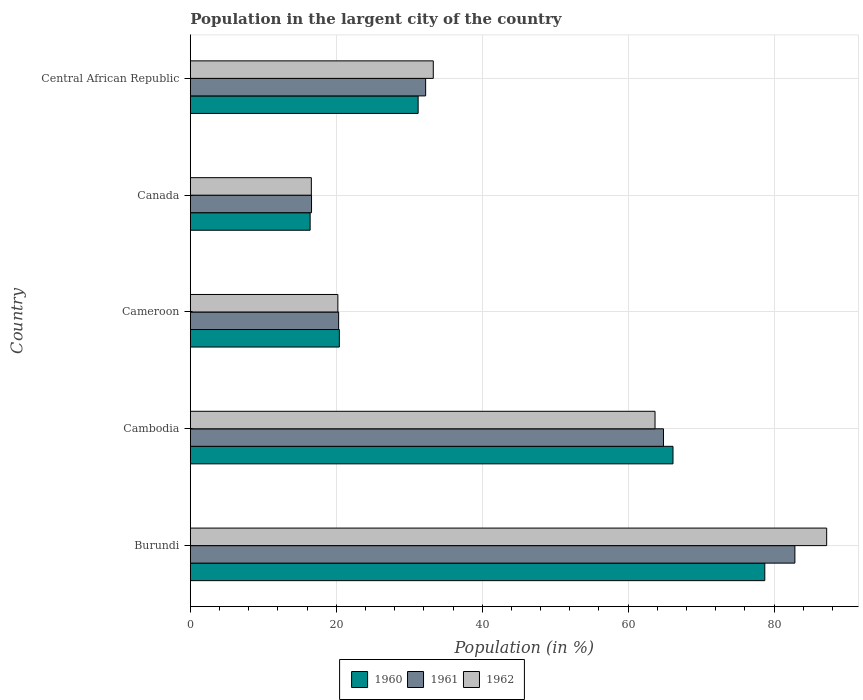How many different coloured bars are there?
Give a very brief answer. 3. Are the number of bars on each tick of the Y-axis equal?
Your response must be concise. Yes. How many bars are there on the 5th tick from the top?
Your answer should be very brief. 3. What is the label of the 4th group of bars from the top?
Offer a very short reply. Cambodia. What is the percentage of population in the largent city in 1960 in Canada?
Give a very brief answer. 16.42. Across all countries, what is the maximum percentage of population in the largent city in 1962?
Your answer should be very brief. 87.2. Across all countries, what is the minimum percentage of population in the largent city in 1962?
Keep it short and to the point. 16.59. In which country was the percentage of population in the largent city in 1962 maximum?
Provide a succinct answer. Burundi. In which country was the percentage of population in the largent city in 1960 minimum?
Your answer should be very brief. Canada. What is the total percentage of population in the largent city in 1961 in the graph?
Your response must be concise. 216.87. What is the difference between the percentage of population in the largent city in 1960 in Burundi and that in Cameroon?
Provide a succinct answer. 58.3. What is the difference between the percentage of population in the largent city in 1962 in Cameroon and the percentage of population in the largent city in 1961 in Cambodia?
Keep it short and to the point. -44.62. What is the average percentage of population in the largent city in 1960 per country?
Ensure brevity in your answer.  42.59. What is the difference between the percentage of population in the largent city in 1961 and percentage of population in the largent city in 1960 in Canada?
Keep it short and to the point. 0.19. What is the ratio of the percentage of population in the largent city in 1961 in Cambodia to that in Cameroon?
Your answer should be compact. 3.19. Is the percentage of population in the largent city in 1961 in Cameroon less than that in Canada?
Make the answer very short. No. Is the difference between the percentage of population in the largent city in 1961 in Cambodia and Canada greater than the difference between the percentage of population in the largent city in 1960 in Cambodia and Canada?
Offer a terse response. No. What is the difference between the highest and the second highest percentage of population in the largent city in 1961?
Your response must be concise. 18.01. What is the difference between the highest and the lowest percentage of population in the largent city in 1960?
Ensure brevity in your answer.  62.3. In how many countries, is the percentage of population in the largent city in 1961 greater than the average percentage of population in the largent city in 1961 taken over all countries?
Offer a terse response. 2. Is the sum of the percentage of population in the largent city in 1961 in Cambodia and Cameroon greater than the maximum percentage of population in the largent city in 1960 across all countries?
Your response must be concise. Yes. What does the 3rd bar from the top in Cambodia represents?
Your answer should be compact. 1960. Is it the case that in every country, the sum of the percentage of population in the largent city in 1960 and percentage of population in the largent city in 1962 is greater than the percentage of population in the largent city in 1961?
Your response must be concise. Yes. How many bars are there?
Keep it short and to the point. 15. How many countries are there in the graph?
Offer a terse response. 5. What is the difference between two consecutive major ticks on the X-axis?
Provide a short and direct response. 20. Are the values on the major ticks of X-axis written in scientific E-notation?
Your answer should be very brief. No. Where does the legend appear in the graph?
Give a very brief answer. Bottom center. How many legend labels are there?
Keep it short and to the point. 3. What is the title of the graph?
Ensure brevity in your answer.  Population in the largent city of the country. Does "1973" appear as one of the legend labels in the graph?
Your answer should be compact. No. What is the label or title of the X-axis?
Keep it short and to the point. Population (in %). What is the label or title of the Y-axis?
Ensure brevity in your answer.  Country. What is the Population (in %) of 1960 in Burundi?
Your answer should be very brief. 78.72. What is the Population (in %) in 1961 in Burundi?
Offer a terse response. 82.84. What is the Population (in %) of 1962 in Burundi?
Ensure brevity in your answer.  87.2. What is the Population (in %) of 1960 in Cambodia?
Keep it short and to the point. 66.14. What is the Population (in %) of 1961 in Cambodia?
Your response must be concise. 64.84. What is the Population (in %) in 1962 in Cambodia?
Keep it short and to the point. 63.68. What is the Population (in %) of 1960 in Cameroon?
Provide a short and direct response. 20.42. What is the Population (in %) in 1961 in Cameroon?
Your answer should be very brief. 20.33. What is the Population (in %) of 1962 in Cameroon?
Provide a short and direct response. 20.22. What is the Population (in %) of 1960 in Canada?
Give a very brief answer. 16.42. What is the Population (in %) in 1961 in Canada?
Your answer should be very brief. 16.61. What is the Population (in %) in 1962 in Canada?
Give a very brief answer. 16.59. What is the Population (in %) in 1960 in Central African Republic?
Make the answer very short. 31.22. What is the Population (in %) in 1961 in Central African Republic?
Your answer should be compact. 32.25. What is the Population (in %) in 1962 in Central African Republic?
Your answer should be very brief. 33.29. Across all countries, what is the maximum Population (in %) of 1960?
Your answer should be compact. 78.72. Across all countries, what is the maximum Population (in %) of 1961?
Make the answer very short. 82.84. Across all countries, what is the maximum Population (in %) in 1962?
Give a very brief answer. 87.2. Across all countries, what is the minimum Population (in %) in 1960?
Offer a very short reply. 16.42. Across all countries, what is the minimum Population (in %) in 1961?
Provide a succinct answer. 16.61. Across all countries, what is the minimum Population (in %) of 1962?
Ensure brevity in your answer.  16.59. What is the total Population (in %) in 1960 in the graph?
Provide a succinct answer. 212.93. What is the total Population (in %) in 1961 in the graph?
Your response must be concise. 216.87. What is the total Population (in %) in 1962 in the graph?
Keep it short and to the point. 220.98. What is the difference between the Population (in %) of 1960 in Burundi and that in Cambodia?
Your answer should be compact. 12.58. What is the difference between the Population (in %) of 1961 in Burundi and that in Cambodia?
Ensure brevity in your answer.  18.01. What is the difference between the Population (in %) in 1962 in Burundi and that in Cambodia?
Your answer should be compact. 23.52. What is the difference between the Population (in %) of 1960 in Burundi and that in Cameroon?
Ensure brevity in your answer.  58.3. What is the difference between the Population (in %) of 1961 in Burundi and that in Cameroon?
Ensure brevity in your answer.  62.52. What is the difference between the Population (in %) in 1962 in Burundi and that in Cameroon?
Your answer should be very brief. 66.98. What is the difference between the Population (in %) of 1960 in Burundi and that in Canada?
Make the answer very short. 62.3. What is the difference between the Population (in %) in 1961 in Burundi and that in Canada?
Offer a very short reply. 66.23. What is the difference between the Population (in %) in 1962 in Burundi and that in Canada?
Keep it short and to the point. 70.61. What is the difference between the Population (in %) in 1960 in Burundi and that in Central African Republic?
Provide a short and direct response. 47.5. What is the difference between the Population (in %) in 1961 in Burundi and that in Central African Republic?
Keep it short and to the point. 50.6. What is the difference between the Population (in %) of 1962 in Burundi and that in Central African Republic?
Your answer should be very brief. 53.9. What is the difference between the Population (in %) in 1960 in Cambodia and that in Cameroon?
Offer a terse response. 45.72. What is the difference between the Population (in %) in 1961 in Cambodia and that in Cameroon?
Keep it short and to the point. 44.51. What is the difference between the Population (in %) of 1962 in Cambodia and that in Cameroon?
Give a very brief answer. 43.46. What is the difference between the Population (in %) in 1960 in Cambodia and that in Canada?
Provide a short and direct response. 49.72. What is the difference between the Population (in %) in 1961 in Cambodia and that in Canada?
Ensure brevity in your answer.  48.23. What is the difference between the Population (in %) of 1962 in Cambodia and that in Canada?
Offer a very short reply. 47.09. What is the difference between the Population (in %) in 1960 in Cambodia and that in Central African Republic?
Your answer should be very brief. 34.92. What is the difference between the Population (in %) in 1961 in Cambodia and that in Central African Republic?
Provide a short and direct response. 32.59. What is the difference between the Population (in %) of 1962 in Cambodia and that in Central African Republic?
Make the answer very short. 30.39. What is the difference between the Population (in %) of 1960 in Cameroon and that in Canada?
Ensure brevity in your answer.  4. What is the difference between the Population (in %) in 1961 in Cameroon and that in Canada?
Your answer should be very brief. 3.71. What is the difference between the Population (in %) in 1962 in Cameroon and that in Canada?
Offer a very short reply. 3.63. What is the difference between the Population (in %) in 1960 in Cameroon and that in Central African Republic?
Your response must be concise. -10.8. What is the difference between the Population (in %) in 1961 in Cameroon and that in Central African Republic?
Give a very brief answer. -11.92. What is the difference between the Population (in %) of 1962 in Cameroon and that in Central African Republic?
Provide a succinct answer. -13.07. What is the difference between the Population (in %) of 1960 in Canada and that in Central African Republic?
Offer a terse response. -14.8. What is the difference between the Population (in %) of 1961 in Canada and that in Central African Republic?
Your answer should be compact. -15.64. What is the difference between the Population (in %) in 1962 in Canada and that in Central African Republic?
Offer a terse response. -16.71. What is the difference between the Population (in %) in 1960 in Burundi and the Population (in %) in 1961 in Cambodia?
Provide a succinct answer. 13.88. What is the difference between the Population (in %) of 1960 in Burundi and the Population (in %) of 1962 in Cambodia?
Give a very brief answer. 15.04. What is the difference between the Population (in %) in 1961 in Burundi and the Population (in %) in 1962 in Cambodia?
Provide a short and direct response. 19.16. What is the difference between the Population (in %) of 1960 in Burundi and the Population (in %) of 1961 in Cameroon?
Offer a very short reply. 58.39. What is the difference between the Population (in %) in 1960 in Burundi and the Population (in %) in 1962 in Cameroon?
Give a very brief answer. 58.5. What is the difference between the Population (in %) of 1961 in Burundi and the Population (in %) of 1962 in Cameroon?
Make the answer very short. 62.62. What is the difference between the Population (in %) of 1960 in Burundi and the Population (in %) of 1961 in Canada?
Your response must be concise. 62.11. What is the difference between the Population (in %) of 1960 in Burundi and the Population (in %) of 1962 in Canada?
Ensure brevity in your answer.  62.13. What is the difference between the Population (in %) of 1961 in Burundi and the Population (in %) of 1962 in Canada?
Your response must be concise. 66.26. What is the difference between the Population (in %) in 1960 in Burundi and the Population (in %) in 1961 in Central African Republic?
Keep it short and to the point. 46.47. What is the difference between the Population (in %) in 1960 in Burundi and the Population (in %) in 1962 in Central African Republic?
Provide a short and direct response. 45.43. What is the difference between the Population (in %) of 1961 in Burundi and the Population (in %) of 1962 in Central African Republic?
Ensure brevity in your answer.  49.55. What is the difference between the Population (in %) in 1960 in Cambodia and the Population (in %) in 1961 in Cameroon?
Ensure brevity in your answer.  45.82. What is the difference between the Population (in %) of 1960 in Cambodia and the Population (in %) of 1962 in Cameroon?
Your response must be concise. 45.92. What is the difference between the Population (in %) of 1961 in Cambodia and the Population (in %) of 1962 in Cameroon?
Offer a very short reply. 44.62. What is the difference between the Population (in %) of 1960 in Cambodia and the Population (in %) of 1961 in Canada?
Ensure brevity in your answer.  49.53. What is the difference between the Population (in %) of 1960 in Cambodia and the Population (in %) of 1962 in Canada?
Provide a succinct answer. 49.56. What is the difference between the Population (in %) in 1961 in Cambodia and the Population (in %) in 1962 in Canada?
Give a very brief answer. 48.25. What is the difference between the Population (in %) in 1960 in Cambodia and the Population (in %) in 1961 in Central African Republic?
Your answer should be very brief. 33.89. What is the difference between the Population (in %) of 1960 in Cambodia and the Population (in %) of 1962 in Central African Republic?
Make the answer very short. 32.85. What is the difference between the Population (in %) in 1961 in Cambodia and the Population (in %) in 1962 in Central African Republic?
Keep it short and to the point. 31.54. What is the difference between the Population (in %) in 1960 in Cameroon and the Population (in %) in 1961 in Canada?
Give a very brief answer. 3.81. What is the difference between the Population (in %) of 1960 in Cameroon and the Population (in %) of 1962 in Canada?
Offer a very short reply. 3.84. What is the difference between the Population (in %) in 1961 in Cameroon and the Population (in %) in 1962 in Canada?
Provide a succinct answer. 3.74. What is the difference between the Population (in %) of 1960 in Cameroon and the Population (in %) of 1961 in Central African Republic?
Provide a short and direct response. -11.82. What is the difference between the Population (in %) in 1960 in Cameroon and the Population (in %) in 1962 in Central African Republic?
Make the answer very short. -12.87. What is the difference between the Population (in %) of 1961 in Cameroon and the Population (in %) of 1962 in Central African Republic?
Keep it short and to the point. -12.97. What is the difference between the Population (in %) of 1960 in Canada and the Population (in %) of 1961 in Central African Republic?
Give a very brief answer. -15.83. What is the difference between the Population (in %) of 1960 in Canada and the Population (in %) of 1962 in Central African Republic?
Make the answer very short. -16.87. What is the difference between the Population (in %) in 1961 in Canada and the Population (in %) in 1962 in Central African Republic?
Keep it short and to the point. -16.68. What is the average Population (in %) of 1960 per country?
Your answer should be very brief. 42.59. What is the average Population (in %) in 1961 per country?
Keep it short and to the point. 43.37. What is the average Population (in %) of 1962 per country?
Your response must be concise. 44.2. What is the difference between the Population (in %) in 1960 and Population (in %) in 1961 in Burundi?
Offer a terse response. -4.12. What is the difference between the Population (in %) in 1960 and Population (in %) in 1962 in Burundi?
Your response must be concise. -8.48. What is the difference between the Population (in %) of 1961 and Population (in %) of 1962 in Burundi?
Make the answer very short. -4.35. What is the difference between the Population (in %) in 1960 and Population (in %) in 1961 in Cambodia?
Offer a very short reply. 1.3. What is the difference between the Population (in %) of 1960 and Population (in %) of 1962 in Cambodia?
Provide a succinct answer. 2.46. What is the difference between the Population (in %) of 1961 and Population (in %) of 1962 in Cambodia?
Your answer should be compact. 1.16. What is the difference between the Population (in %) in 1960 and Population (in %) in 1961 in Cameroon?
Provide a short and direct response. 0.1. What is the difference between the Population (in %) of 1960 and Population (in %) of 1962 in Cameroon?
Your response must be concise. 0.2. What is the difference between the Population (in %) of 1961 and Population (in %) of 1962 in Cameroon?
Your answer should be very brief. 0.11. What is the difference between the Population (in %) of 1960 and Population (in %) of 1961 in Canada?
Provide a short and direct response. -0.19. What is the difference between the Population (in %) of 1960 and Population (in %) of 1962 in Canada?
Give a very brief answer. -0.16. What is the difference between the Population (in %) of 1961 and Population (in %) of 1962 in Canada?
Provide a short and direct response. 0.03. What is the difference between the Population (in %) of 1960 and Population (in %) of 1961 in Central African Republic?
Provide a succinct answer. -1.03. What is the difference between the Population (in %) in 1960 and Population (in %) in 1962 in Central African Republic?
Provide a short and direct response. -2.07. What is the difference between the Population (in %) of 1961 and Population (in %) of 1962 in Central African Republic?
Your response must be concise. -1.05. What is the ratio of the Population (in %) in 1960 in Burundi to that in Cambodia?
Your answer should be compact. 1.19. What is the ratio of the Population (in %) in 1961 in Burundi to that in Cambodia?
Provide a succinct answer. 1.28. What is the ratio of the Population (in %) in 1962 in Burundi to that in Cambodia?
Keep it short and to the point. 1.37. What is the ratio of the Population (in %) of 1960 in Burundi to that in Cameroon?
Your answer should be compact. 3.85. What is the ratio of the Population (in %) of 1961 in Burundi to that in Cameroon?
Offer a very short reply. 4.08. What is the ratio of the Population (in %) of 1962 in Burundi to that in Cameroon?
Ensure brevity in your answer.  4.31. What is the ratio of the Population (in %) in 1960 in Burundi to that in Canada?
Provide a short and direct response. 4.79. What is the ratio of the Population (in %) of 1961 in Burundi to that in Canada?
Offer a very short reply. 4.99. What is the ratio of the Population (in %) of 1962 in Burundi to that in Canada?
Ensure brevity in your answer.  5.26. What is the ratio of the Population (in %) of 1960 in Burundi to that in Central African Republic?
Offer a very short reply. 2.52. What is the ratio of the Population (in %) in 1961 in Burundi to that in Central African Republic?
Your response must be concise. 2.57. What is the ratio of the Population (in %) in 1962 in Burundi to that in Central African Republic?
Provide a succinct answer. 2.62. What is the ratio of the Population (in %) in 1960 in Cambodia to that in Cameroon?
Offer a terse response. 3.24. What is the ratio of the Population (in %) of 1961 in Cambodia to that in Cameroon?
Provide a succinct answer. 3.19. What is the ratio of the Population (in %) of 1962 in Cambodia to that in Cameroon?
Your answer should be compact. 3.15. What is the ratio of the Population (in %) in 1960 in Cambodia to that in Canada?
Your response must be concise. 4.03. What is the ratio of the Population (in %) of 1961 in Cambodia to that in Canada?
Your response must be concise. 3.9. What is the ratio of the Population (in %) of 1962 in Cambodia to that in Canada?
Your answer should be very brief. 3.84. What is the ratio of the Population (in %) in 1960 in Cambodia to that in Central African Republic?
Your answer should be compact. 2.12. What is the ratio of the Population (in %) of 1961 in Cambodia to that in Central African Republic?
Give a very brief answer. 2.01. What is the ratio of the Population (in %) in 1962 in Cambodia to that in Central African Republic?
Your response must be concise. 1.91. What is the ratio of the Population (in %) in 1960 in Cameroon to that in Canada?
Your answer should be very brief. 1.24. What is the ratio of the Population (in %) in 1961 in Cameroon to that in Canada?
Make the answer very short. 1.22. What is the ratio of the Population (in %) of 1962 in Cameroon to that in Canada?
Keep it short and to the point. 1.22. What is the ratio of the Population (in %) in 1960 in Cameroon to that in Central African Republic?
Offer a terse response. 0.65. What is the ratio of the Population (in %) of 1961 in Cameroon to that in Central African Republic?
Your answer should be very brief. 0.63. What is the ratio of the Population (in %) in 1962 in Cameroon to that in Central African Republic?
Your answer should be compact. 0.61. What is the ratio of the Population (in %) of 1960 in Canada to that in Central African Republic?
Make the answer very short. 0.53. What is the ratio of the Population (in %) of 1961 in Canada to that in Central African Republic?
Offer a terse response. 0.52. What is the ratio of the Population (in %) of 1962 in Canada to that in Central African Republic?
Provide a succinct answer. 0.5. What is the difference between the highest and the second highest Population (in %) in 1960?
Ensure brevity in your answer.  12.58. What is the difference between the highest and the second highest Population (in %) of 1961?
Provide a succinct answer. 18.01. What is the difference between the highest and the second highest Population (in %) in 1962?
Ensure brevity in your answer.  23.52. What is the difference between the highest and the lowest Population (in %) of 1960?
Provide a short and direct response. 62.3. What is the difference between the highest and the lowest Population (in %) in 1961?
Provide a short and direct response. 66.23. What is the difference between the highest and the lowest Population (in %) in 1962?
Your answer should be very brief. 70.61. 